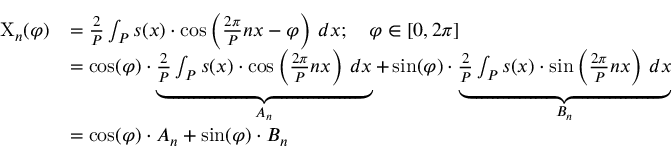<formula> <loc_0><loc_0><loc_500><loc_500>{ \begin{array} { r l } { X _ { n } ( \varphi ) } & { = { \frac { 2 } { P } } \int _ { P } s ( x ) \cdot \cos \left ( { \frac { 2 \pi } { P } } n x - \varphi \right ) \, d x ; \quad \varphi \in [ 0 , 2 \pi ] } \\ & { = \cos ( \varphi ) \cdot \underbrace { { \frac { 2 } { P } } \int _ { P } s ( x ) \cdot \cos \left ( { \frac { 2 \pi } { P } } n x \right ) \, d x } _ { A _ { n } } + \sin ( \varphi ) \cdot \underbrace { { \frac { 2 } { P } } \int _ { P } s ( x ) \cdot \sin \left ( { \frac { 2 \pi } { P } } n x \right ) \, d x } _ { B _ { n } } } \\ & { = \cos ( \varphi ) \cdot A _ { n } + \sin ( \varphi ) \cdot B _ { n } } \end{array} }</formula> 